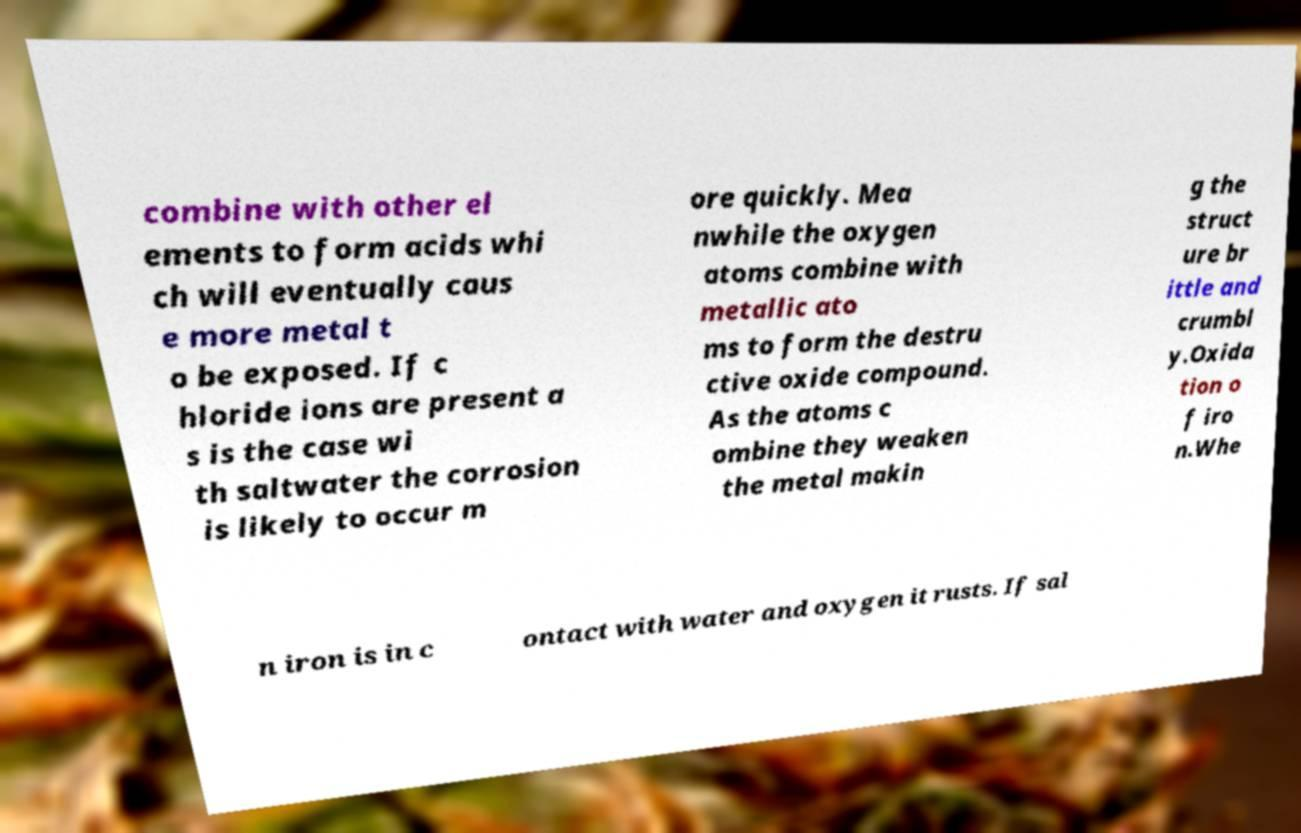Could you assist in decoding the text presented in this image and type it out clearly? combine with other el ements to form acids whi ch will eventually caus e more metal t o be exposed. If c hloride ions are present a s is the case wi th saltwater the corrosion is likely to occur m ore quickly. Mea nwhile the oxygen atoms combine with metallic ato ms to form the destru ctive oxide compound. As the atoms c ombine they weaken the metal makin g the struct ure br ittle and crumbl y.Oxida tion o f iro n.Whe n iron is in c ontact with water and oxygen it rusts. If sal 